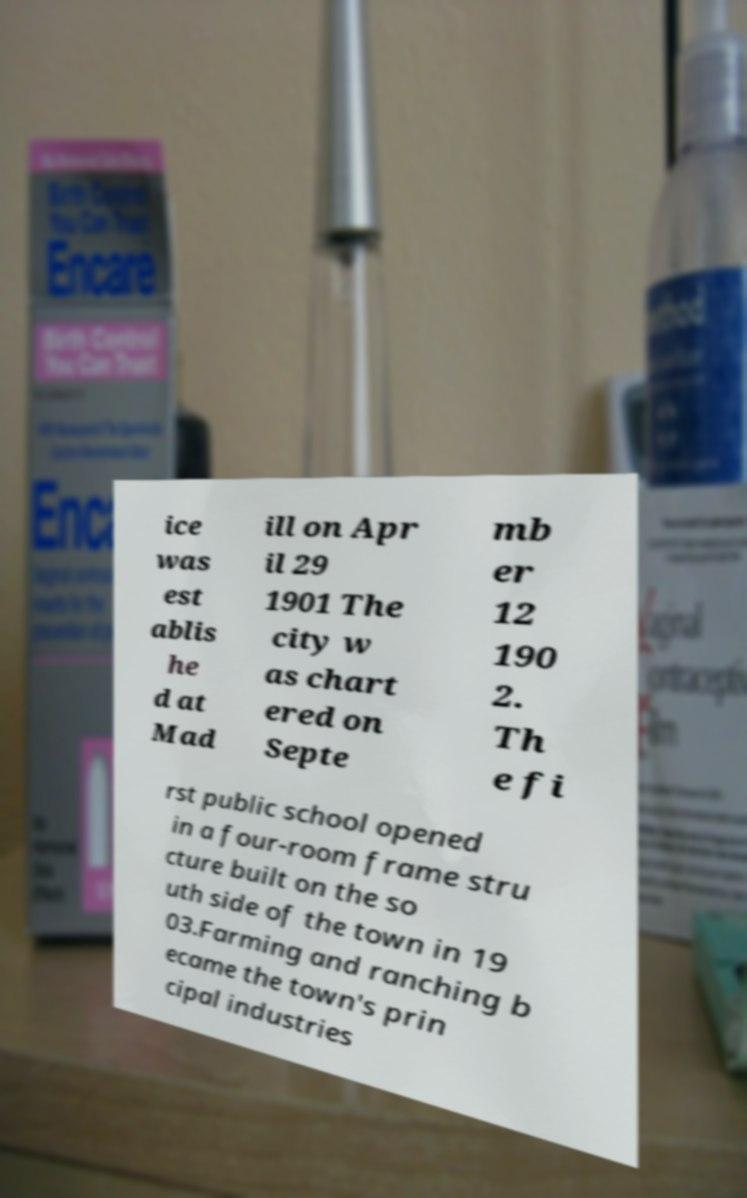There's text embedded in this image that I need extracted. Can you transcribe it verbatim? ice was est ablis he d at Mad ill on Apr il 29 1901 The city w as chart ered on Septe mb er 12 190 2. Th e fi rst public school opened in a four-room frame stru cture built on the so uth side of the town in 19 03.Farming and ranching b ecame the town's prin cipal industries 